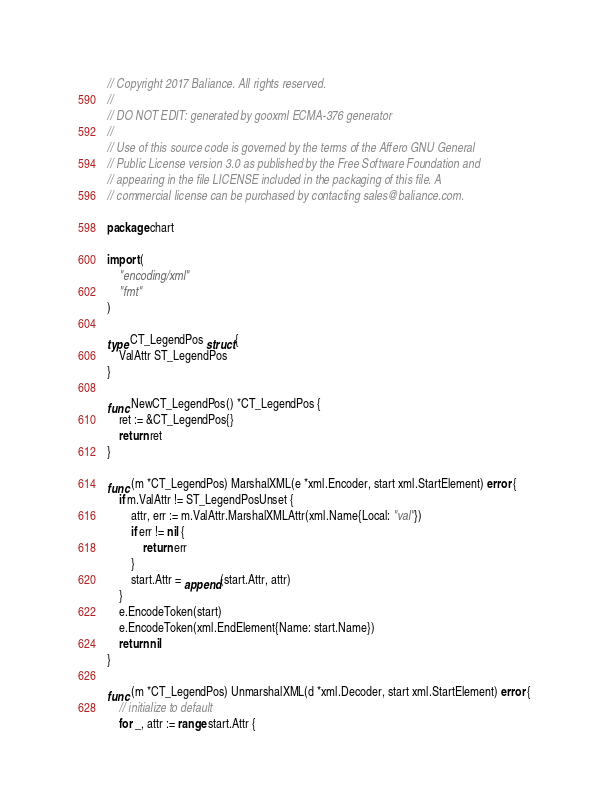<code> <loc_0><loc_0><loc_500><loc_500><_Go_>// Copyright 2017 Baliance. All rights reserved.
//
// DO NOT EDIT: generated by gooxml ECMA-376 generator
//
// Use of this source code is governed by the terms of the Affero GNU General
// Public License version 3.0 as published by the Free Software Foundation and
// appearing in the file LICENSE included in the packaging of this file. A
// commercial license can be purchased by contacting sales@baliance.com.

package chart

import (
	"encoding/xml"
	"fmt"
)

type CT_LegendPos struct {
	ValAttr ST_LegendPos
}

func NewCT_LegendPos() *CT_LegendPos {
	ret := &CT_LegendPos{}
	return ret
}

func (m *CT_LegendPos) MarshalXML(e *xml.Encoder, start xml.StartElement) error {
	if m.ValAttr != ST_LegendPosUnset {
		attr, err := m.ValAttr.MarshalXMLAttr(xml.Name{Local: "val"})
		if err != nil {
			return err
		}
		start.Attr = append(start.Attr, attr)
	}
	e.EncodeToken(start)
	e.EncodeToken(xml.EndElement{Name: start.Name})
	return nil
}

func (m *CT_LegendPos) UnmarshalXML(d *xml.Decoder, start xml.StartElement) error {
	// initialize to default
	for _, attr := range start.Attr {</code> 